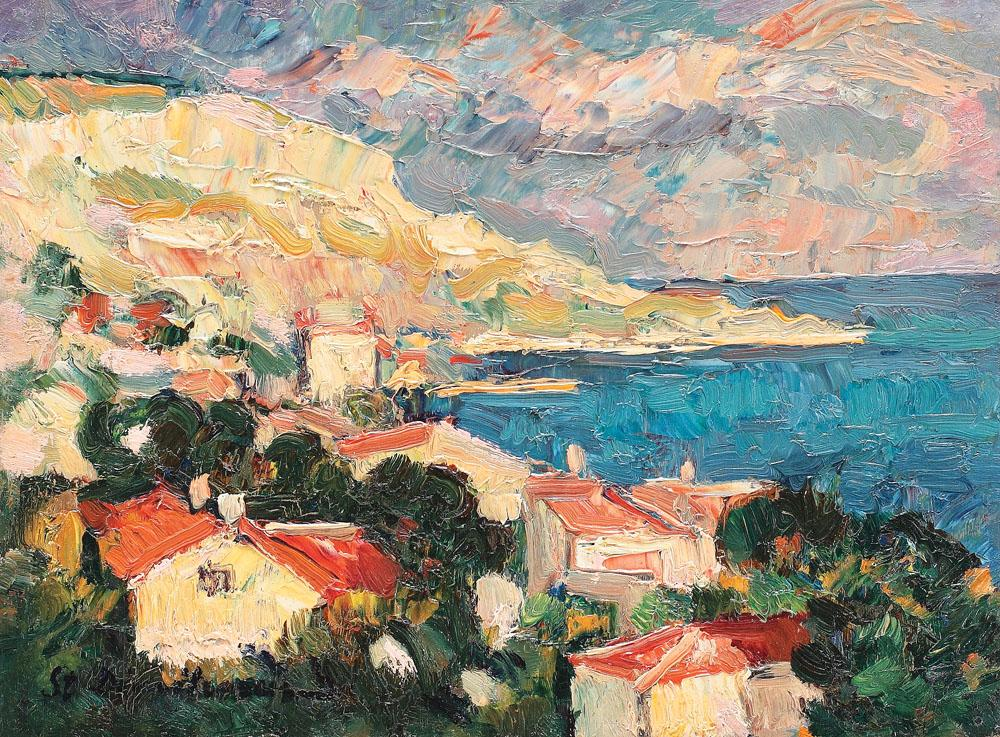What might be the historical or cultural significance of this coastal village scene? This coastal village scene could be significant in several cultural or historical contexts. Impressively captured in an impressionist style, it might depict a specific location known for its picturesque landscapes and possibly a rich maritime history. Culturally, such villages often serve as hubs of local tradition, craftsmanship, and community life, possibly reflecting a lifestyle deeply intertwined with the sea. Historically, these settings could also echo stories of trade, fishing, and cultural exchange that coastal villages typically facilitate. The artist's emphasis on vivid colors and dynamic light might be suggesting not just the physical beauty of the place but also its vibrant cultural life. 